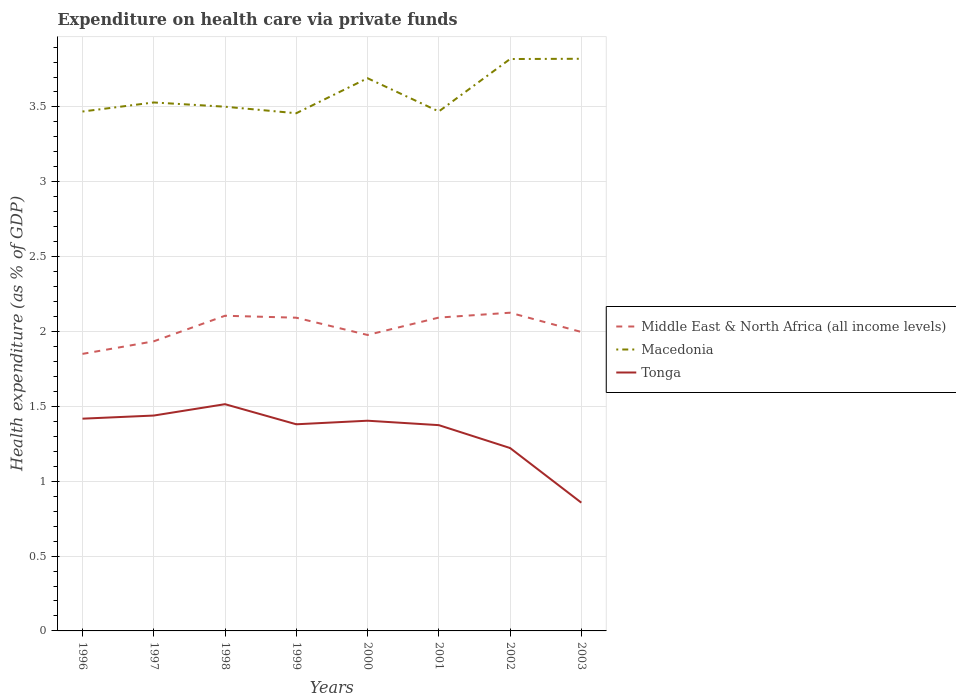How many different coloured lines are there?
Keep it short and to the point. 3. Is the number of lines equal to the number of legend labels?
Your answer should be very brief. Yes. Across all years, what is the maximum expenditure made on health care in Macedonia?
Ensure brevity in your answer.  3.46. In which year was the expenditure made on health care in Tonga maximum?
Make the answer very short. 2003. What is the total expenditure made on health care in Middle East & North Africa (all income levels) in the graph?
Ensure brevity in your answer.  0.11. What is the difference between the highest and the second highest expenditure made on health care in Middle East & North Africa (all income levels)?
Offer a terse response. 0.28. What is the difference between the highest and the lowest expenditure made on health care in Tonga?
Your answer should be very brief. 6. How many years are there in the graph?
Offer a very short reply. 8. What is the difference between two consecutive major ticks on the Y-axis?
Your answer should be compact. 0.5. Are the values on the major ticks of Y-axis written in scientific E-notation?
Your answer should be compact. No. Does the graph contain grids?
Your response must be concise. Yes. Where does the legend appear in the graph?
Provide a succinct answer. Center right. How are the legend labels stacked?
Make the answer very short. Vertical. What is the title of the graph?
Provide a short and direct response. Expenditure on health care via private funds. What is the label or title of the Y-axis?
Offer a terse response. Health expenditure (as % of GDP). What is the Health expenditure (as % of GDP) of Middle East & North Africa (all income levels) in 1996?
Keep it short and to the point. 1.85. What is the Health expenditure (as % of GDP) in Macedonia in 1996?
Provide a succinct answer. 3.47. What is the Health expenditure (as % of GDP) of Tonga in 1996?
Give a very brief answer. 1.42. What is the Health expenditure (as % of GDP) of Middle East & North Africa (all income levels) in 1997?
Your response must be concise. 1.93. What is the Health expenditure (as % of GDP) in Macedonia in 1997?
Offer a very short reply. 3.53. What is the Health expenditure (as % of GDP) in Tonga in 1997?
Ensure brevity in your answer.  1.44. What is the Health expenditure (as % of GDP) of Middle East & North Africa (all income levels) in 1998?
Offer a very short reply. 2.11. What is the Health expenditure (as % of GDP) in Macedonia in 1998?
Make the answer very short. 3.5. What is the Health expenditure (as % of GDP) of Tonga in 1998?
Ensure brevity in your answer.  1.51. What is the Health expenditure (as % of GDP) in Middle East & North Africa (all income levels) in 1999?
Provide a short and direct response. 2.09. What is the Health expenditure (as % of GDP) of Macedonia in 1999?
Your answer should be compact. 3.46. What is the Health expenditure (as % of GDP) of Tonga in 1999?
Your answer should be compact. 1.38. What is the Health expenditure (as % of GDP) in Middle East & North Africa (all income levels) in 2000?
Give a very brief answer. 1.98. What is the Health expenditure (as % of GDP) of Macedonia in 2000?
Provide a short and direct response. 3.69. What is the Health expenditure (as % of GDP) of Tonga in 2000?
Give a very brief answer. 1.4. What is the Health expenditure (as % of GDP) of Middle East & North Africa (all income levels) in 2001?
Ensure brevity in your answer.  2.09. What is the Health expenditure (as % of GDP) of Macedonia in 2001?
Ensure brevity in your answer.  3.47. What is the Health expenditure (as % of GDP) of Tonga in 2001?
Your answer should be very brief. 1.37. What is the Health expenditure (as % of GDP) in Middle East & North Africa (all income levels) in 2002?
Your answer should be very brief. 2.13. What is the Health expenditure (as % of GDP) of Macedonia in 2002?
Keep it short and to the point. 3.82. What is the Health expenditure (as % of GDP) in Tonga in 2002?
Offer a very short reply. 1.22. What is the Health expenditure (as % of GDP) of Middle East & North Africa (all income levels) in 2003?
Offer a terse response. 2. What is the Health expenditure (as % of GDP) in Macedonia in 2003?
Ensure brevity in your answer.  3.82. What is the Health expenditure (as % of GDP) of Tonga in 2003?
Make the answer very short. 0.86. Across all years, what is the maximum Health expenditure (as % of GDP) of Middle East & North Africa (all income levels)?
Provide a succinct answer. 2.13. Across all years, what is the maximum Health expenditure (as % of GDP) in Macedonia?
Provide a short and direct response. 3.82. Across all years, what is the maximum Health expenditure (as % of GDP) of Tonga?
Provide a succinct answer. 1.51. Across all years, what is the minimum Health expenditure (as % of GDP) in Middle East & North Africa (all income levels)?
Give a very brief answer. 1.85. Across all years, what is the minimum Health expenditure (as % of GDP) in Macedonia?
Offer a terse response. 3.46. Across all years, what is the minimum Health expenditure (as % of GDP) in Tonga?
Your response must be concise. 0.86. What is the total Health expenditure (as % of GDP) of Middle East & North Africa (all income levels) in the graph?
Provide a succinct answer. 16.18. What is the total Health expenditure (as % of GDP) in Macedonia in the graph?
Your response must be concise. 28.76. What is the total Health expenditure (as % of GDP) of Tonga in the graph?
Offer a very short reply. 10.61. What is the difference between the Health expenditure (as % of GDP) in Middle East & North Africa (all income levels) in 1996 and that in 1997?
Your answer should be very brief. -0.08. What is the difference between the Health expenditure (as % of GDP) in Macedonia in 1996 and that in 1997?
Your answer should be compact. -0.06. What is the difference between the Health expenditure (as % of GDP) in Tonga in 1996 and that in 1997?
Provide a short and direct response. -0.02. What is the difference between the Health expenditure (as % of GDP) of Middle East & North Africa (all income levels) in 1996 and that in 1998?
Your answer should be compact. -0.25. What is the difference between the Health expenditure (as % of GDP) in Macedonia in 1996 and that in 1998?
Your answer should be very brief. -0.03. What is the difference between the Health expenditure (as % of GDP) in Tonga in 1996 and that in 1998?
Ensure brevity in your answer.  -0.1. What is the difference between the Health expenditure (as % of GDP) in Middle East & North Africa (all income levels) in 1996 and that in 1999?
Make the answer very short. -0.24. What is the difference between the Health expenditure (as % of GDP) of Macedonia in 1996 and that in 1999?
Ensure brevity in your answer.  0.01. What is the difference between the Health expenditure (as % of GDP) in Tonga in 1996 and that in 1999?
Your answer should be very brief. 0.04. What is the difference between the Health expenditure (as % of GDP) of Middle East & North Africa (all income levels) in 1996 and that in 2000?
Your response must be concise. -0.13. What is the difference between the Health expenditure (as % of GDP) in Macedonia in 1996 and that in 2000?
Give a very brief answer. -0.22. What is the difference between the Health expenditure (as % of GDP) of Tonga in 1996 and that in 2000?
Offer a very short reply. 0.01. What is the difference between the Health expenditure (as % of GDP) of Middle East & North Africa (all income levels) in 1996 and that in 2001?
Keep it short and to the point. -0.24. What is the difference between the Health expenditure (as % of GDP) of Macedonia in 1996 and that in 2001?
Your response must be concise. -0. What is the difference between the Health expenditure (as % of GDP) in Tonga in 1996 and that in 2001?
Your response must be concise. 0.04. What is the difference between the Health expenditure (as % of GDP) of Middle East & North Africa (all income levels) in 1996 and that in 2002?
Provide a succinct answer. -0.28. What is the difference between the Health expenditure (as % of GDP) of Macedonia in 1996 and that in 2002?
Your answer should be very brief. -0.35. What is the difference between the Health expenditure (as % of GDP) in Tonga in 1996 and that in 2002?
Provide a succinct answer. 0.2. What is the difference between the Health expenditure (as % of GDP) in Middle East & North Africa (all income levels) in 1996 and that in 2003?
Offer a very short reply. -0.15. What is the difference between the Health expenditure (as % of GDP) of Macedonia in 1996 and that in 2003?
Keep it short and to the point. -0.35. What is the difference between the Health expenditure (as % of GDP) in Tonga in 1996 and that in 2003?
Offer a very short reply. 0.56. What is the difference between the Health expenditure (as % of GDP) of Middle East & North Africa (all income levels) in 1997 and that in 1998?
Your answer should be very brief. -0.17. What is the difference between the Health expenditure (as % of GDP) of Macedonia in 1997 and that in 1998?
Provide a short and direct response. 0.03. What is the difference between the Health expenditure (as % of GDP) in Tonga in 1997 and that in 1998?
Your response must be concise. -0.08. What is the difference between the Health expenditure (as % of GDP) in Middle East & North Africa (all income levels) in 1997 and that in 1999?
Provide a short and direct response. -0.16. What is the difference between the Health expenditure (as % of GDP) in Macedonia in 1997 and that in 1999?
Provide a short and direct response. 0.07. What is the difference between the Health expenditure (as % of GDP) in Tonga in 1997 and that in 1999?
Provide a short and direct response. 0.06. What is the difference between the Health expenditure (as % of GDP) in Middle East & North Africa (all income levels) in 1997 and that in 2000?
Make the answer very short. -0.04. What is the difference between the Health expenditure (as % of GDP) in Macedonia in 1997 and that in 2000?
Ensure brevity in your answer.  -0.16. What is the difference between the Health expenditure (as % of GDP) in Tonga in 1997 and that in 2000?
Your answer should be compact. 0.03. What is the difference between the Health expenditure (as % of GDP) of Middle East & North Africa (all income levels) in 1997 and that in 2001?
Offer a very short reply. -0.16. What is the difference between the Health expenditure (as % of GDP) of Macedonia in 1997 and that in 2001?
Provide a succinct answer. 0.06. What is the difference between the Health expenditure (as % of GDP) of Tonga in 1997 and that in 2001?
Make the answer very short. 0.06. What is the difference between the Health expenditure (as % of GDP) of Middle East & North Africa (all income levels) in 1997 and that in 2002?
Make the answer very short. -0.19. What is the difference between the Health expenditure (as % of GDP) of Macedonia in 1997 and that in 2002?
Your answer should be compact. -0.29. What is the difference between the Health expenditure (as % of GDP) of Tonga in 1997 and that in 2002?
Your answer should be compact. 0.22. What is the difference between the Health expenditure (as % of GDP) of Middle East & North Africa (all income levels) in 1997 and that in 2003?
Make the answer very short. -0.06. What is the difference between the Health expenditure (as % of GDP) of Macedonia in 1997 and that in 2003?
Ensure brevity in your answer.  -0.29. What is the difference between the Health expenditure (as % of GDP) in Tonga in 1997 and that in 2003?
Your answer should be compact. 0.58. What is the difference between the Health expenditure (as % of GDP) of Middle East & North Africa (all income levels) in 1998 and that in 1999?
Provide a succinct answer. 0.01. What is the difference between the Health expenditure (as % of GDP) of Macedonia in 1998 and that in 1999?
Give a very brief answer. 0.04. What is the difference between the Health expenditure (as % of GDP) in Tonga in 1998 and that in 1999?
Your answer should be very brief. 0.13. What is the difference between the Health expenditure (as % of GDP) in Middle East & North Africa (all income levels) in 1998 and that in 2000?
Provide a short and direct response. 0.13. What is the difference between the Health expenditure (as % of GDP) in Macedonia in 1998 and that in 2000?
Ensure brevity in your answer.  -0.19. What is the difference between the Health expenditure (as % of GDP) of Tonga in 1998 and that in 2000?
Ensure brevity in your answer.  0.11. What is the difference between the Health expenditure (as % of GDP) of Middle East & North Africa (all income levels) in 1998 and that in 2001?
Your response must be concise. 0.01. What is the difference between the Health expenditure (as % of GDP) in Macedonia in 1998 and that in 2001?
Keep it short and to the point. 0.03. What is the difference between the Health expenditure (as % of GDP) of Tonga in 1998 and that in 2001?
Provide a short and direct response. 0.14. What is the difference between the Health expenditure (as % of GDP) of Middle East & North Africa (all income levels) in 1998 and that in 2002?
Provide a short and direct response. -0.02. What is the difference between the Health expenditure (as % of GDP) of Macedonia in 1998 and that in 2002?
Your response must be concise. -0.32. What is the difference between the Health expenditure (as % of GDP) of Tonga in 1998 and that in 2002?
Ensure brevity in your answer.  0.29. What is the difference between the Health expenditure (as % of GDP) in Middle East & North Africa (all income levels) in 1998 and that in 2003?
Offer a terse response. 0.11. What is the difference between the Health expenditure (as % of GDP) in Macedonia in 1998 and that in 2003?
Provide a short and direct response. -0.32. What is the difference between the Health expenditure (as % of GDP) of Tonga in 1998 and that in 2003?
Give a very brief answer. 0.66. What is the difference between the Health expenditure (as % of GDP) of Middle East & North Africa (all income levels) in 1999 and that in 2000?
Make the answer very short. 0.12. What is the difference between the Health expenditure (as % of GDP) of Macedonia in 1999 and that in 2000?
Keep it short and to the point. -0.23. What is the difference between the Health expenditure (as % of GDP) of Tonga in 1999 and that in 2000?
Give a very brief answer. -0.02. What is the difference between the Health expenditure (as % of GDP) in Middle East & North Africa (all income levels) in 1999 and that in 2001?
Make the answer very short. -0. What is the difference between the Health expenditure (as % of GDP) of Macedonia in 1999 and that in 2001?
Keep it short and to the point. -0.01. What is the difference between the Health expenditure (as % of GDP) of Tonga in 1999 and that in 2001?
Make the answer very short. 0.01. What is the difference between the Health expenditure (as % of GDP) in Middle East & North Africa (all income levels) in 1999 and that in 2002?
Provide a succinct answer. -0.03. What is the difference between the Health expenditure (as % of GDP) of Macedonia in 1999 and that in 2002?
Your answer should be very brief. -0.36. What is the difference between the Health expenditure (as % of GDP) in Tonga in 1999 and that in 2002?
Provide a succinct answer. 0.16. What is the difference between the Health expenditure (as % of GDP) of Middle East & North Africa (all income levels) in 1999 and that in 2003?
Offer a terse response. 0.1. What is the difference between the Health expenditure (as % of GDP) of Macedonia in 1999 and that in 2003?
Provide a short and direct response. -0.36. What is the difference between the Health expenditure (as % of GDP) in Tonga in 1999 and that in 2003?
Your answer should be very brief. 0.52. What is the difference between the Health expenditure (as % of GDP) in Middle East & North Africa (all income levels) in 2000 and that in 2001?
Provide a succinct answer. -0.12. What is the difference between the Health expenditure (as % of GDP) in Macedonia in 2000 and that in 2001?
Make the answer very short. 0.22. What is the difference between the Health expenditure (as % of GDP) in Tonga in 2000 and that in 2001?
Provide a succinct answer. 0.03. What is the difference between the Health expenditure (as % of GDP) of Middle East & North Africa (all income levels) in 2000 and that in 2002?
Keep it short and to the point. -0.15. What is the difference between the Health expenditure (as % of GDP) of Macedonia in 2000 and that in 2002?
Offer a very short reply. -0.13. What is the difference between the Health expenditure (as % of GDP) in Tonga in 2000 and that in 2002?
Give a very brief answer. 0.18. What is the difference between the Health expenditure (as % of GDP) of Middle East & North Africa (all income levels) in 2000 and that in 2003?
Your response must be concise. -0.02. What is the difference between the Health expenditure (as % of GDP) in Macedonia in 2000 and that in 2003?
Ensure brevity in your answer.  -0.13. What is the difference between the Health expenditure (as % of GDP) of Tonga in 2000 and that in 2003?
Your answer should be compact. 0.55. What is the difference between the Health expenditure (as % of GDP) of Middle East & North Africa (all income levels) in 2001 and that in 2002?
Provide a short and direct response. -0.03. What is the difference between the Health expenditure (as % of GDP) of Macedonia in 2001 and that in 2002?
Offer a very short reply. -0.35. What is the difference between the Health expenditure (as % of GDP) in Tonga in 2001 and that in 2002?
Provide a succinct answer. 0.15. What is the difference between the Health expenditure (as % of GDP) of Middle East & North Africa (all income levels) in 2001 and that in 2003?
Provide a short and direct response. 0.1. What is the difference between the Health expenditure (as % of GDP) in Macedonia in 2001 and that in 2003?
Provide a short and direct response. -0.35. What is the difference between the Health expenditure (as % of GDP) of Tonga in 2001 and that in 2003?
Offer a terse response. 0.52. What is the difference between the Health expenditure (as % of GDP) in Middle East & North Africa (all income levels) in 2002 and that in 2003?
Your answer should be compact. 0.13. What is the difference between the Health expenditure (as % of GDP) in Macedonia in 2002 and that in 2003?
Make the answer very short. -0. What is the difference between the Health expenditure (as % of GDP) in Tonga in 2002 and that in 2003?
Give a very brief answer. 0.37. What is the difference between the Health expenditure (as % of GDP) of Middle East & North Africa (all income levels) in 1996 and the Health expenditure (as % of GDP) of Macedonia in 1997?
Your answer should be compact. -1.68. What is the difference between the Health expenditure (as % of GDP) in Middle East & North Africa (all income levels) in 1996 and the Health expenditure (as % of GDP) in Tonga in 1997?
Offer a very short reply. 0.41. What is the difference between the Health expenditure (as % of GDP) of Macedonia in 1996 and the Health expenditure (as % of GDP) of Tonga in 1997?
Ensure brevity in your answer.  2.03. What is the difference between the Health expenditure (as % of GDP) in Middle East & North Africa (all income levels) in 1996 and the Health expenditure (as % of GDP) in Macedonia in 1998?
Keep it short and to the point. -1.65. What is the difference between the Health expenditure (as % of GDP) of Middle East & North Africa (all income levels) in 1996 and the Health expenditure (as % of GDP) of Tonga in 1998?
Provide a short and direct response. 0.34. What is the difference between the Health expenditure (as % of GDP) in Macedonia in 1996 and the Health expenditure (as % of GDP) in Tonga in 1998?
Make the answer very short. 1.96. What is the difference between the Health expenditure (as % of GDP) in Middle East & North Africa (all income levels) in 1996 and the Health expenditure (as % of GDP) in Macedonia in 1999?
Ensure brevity in your answer.  -1.61. What is the difference between the Health expenditure (as % of GDP) of Middle East & North Africa (all income levels) in 1996 and the Health expenditure (as % of GDP) of Tonga in 1999?
Your answer should be compact. 0.47. What is the difference between the Health expenditure (as % of GDP) of Macedonia in 1996 and the Health expenditure (as % of GDP) of Tonga in 1999?
Make the answer very short. 2.09. What is the difference between the Health expenditure (as % of GDP) in Middle East & North Africa (all income levels) in 1996 and the Health expenditure (as % of GDP) in Macedonia in 2000?
Your answer should be very brief. -1.84. What is the difference between the Health expenditure (as % of GDP) in Middle East & North Africa (all income levels) in 1996 and the Health expenditure (as % of GDP) in Tonga in 2000?
Your response must be concise. 0.45. What is the difference between the Health expenditure (as % of GDP) of Macedonia in 1996 and the Health expenditure (as % of GDP) of Tonga in 2000?
Your answer should be compact. 2.07. What is the difference between the Health expenditure (as % of GDP) in Middle East & North Africa (all income levels) in 1996 and the Health expenditure (as % of GDP) in Macedonia in 2001?
Ensure brevity in your answer.  -1.62. What is the difference between the Health expenditure (as % of GDP) of Middle East & North Africa (all income levels) in 1996 and the Health expenditure (as % of GDP) of Tonga in 2001?
Give a very brief answer. 0.48. What is the difference between the Health expenditure (as % of GDP) of Macedonia in 1996 and the Health expenditure (as % of GDP) of Tonga in 2001?
Ensure brevity in your answer.  2.1. What is the difference between the Health expenditure (as % of GDP) in Middle East & North Africa (all income levels) in 1996 and the Health expenditure (as % of GDP) in Macedonia in 2002?
Offer a very short reply. -1.97. What is the difference between the Health expenditure (as % of GDP) in Middle East & North Africa (all income levels) in 1996 and the Health expenditure (as % of GDP) in Tonga in 2002?
Ensure brevity in your answer.  0.63. What is the difference between the Health expenditure (as % of GDP) in Macedonia in 1996 and the Health expenditure (as % of GDP) in Tonga in 2002?
Provide a succinct answer. 2.25. What is the difference between the Health expenditure (as % of GDP) in Middle East & North Africa (all income levels) in 1996 and the Health expenditure (as % of GDP) in Macedonia in 2003?
Your response must be concise. -1.97. What is the difference between the Health expenditure (as % of GDP) of Macedonia in 1996 and the Health expenditure (as % of GDP) of Tonga in 2003?
Your answer should be compact. 2.61. What is the difference between the Health expenditure (as % of GDP) in Middle East & North Africa (all income levels) in 1997 and the Health expenditure (as % of GDP) in Macedonia in 1998?
Offer a very short reply. -1.57. What is the difference between the Health expenditure (as % of GDP) in Middle East & North Africa (all income levels) in 1997 and the Health expenditure (as % of GDP) in Tonga in 1998?
Offer a terse response. 0.42. What is the difference between the Health expenditure (as % of GDP) in Macedonia in 1997 and the Health expenditure (as % of GDP) in Tonga in 1998?
Make the answer very short. 2.02. What is the difference between the Health expenditure (as % of GDP) in Middle East & North Africa (all income levels) in 1997 and the Health expenditure (as % of GDP) in Macedonia in 1999?
Your response must be concise. -1.52. What is the difference between the Health expenditure (as % of GDP) of Middle East & North Africa (all income levels) in 1997 and the Health expenditure (as % of GDP) of Tonga in 1999?
Your response must be concise. 0.55. What is the difference between the Health expenditure (as % of GDP) in Macedonia in 1997 and the Health expenditure (as % of GDP) in Tonga in 1999?
Your response must be concise. 2.15. What is the difference between the Health expenditure (as % of GDP) in Middle East & North Africa (all income levels) in 1997 and the Health expenditure (as % of GDP) in Macedonia in 2000?
Your response must be concise. -1.76. What is the difference between the Health expenditure (as % of GDP) of Middle East & North Africa (all income levels) in 1997 and the Health expenditure (as % of GDP) of Tonga in 2000?
Provide a succinct answer. 0.53. What is the difference between the Health expenditure (as % of GDP) of Macedonia in 1997 and the Health expenditure (as % of GDP) of Tonga in 2000?
Ensure brevity in your answer.  2.13. What is the difference between the Health expenditure (as % of GDP) of Middle East & North Africa (all income levels) in 1997 and the Health expenditure (as % of GDP) of Macedonia in 2001?
Ensure brevity in your answer.  -1.54. What is the difference between the Health expenditure (as % of GDP) in Middle East & North Africa (all income levels) in 1997 and the Health expenditure (as % of GDP) in Tonga in 2001?
Offer a very short reply. 0.56. What is the difference between the Health expenditure (as % of GDP) of Macedonia in 1997 and the Health expenditure (as % of GDP) of Tonga in 2001?
Your answer should be very brief. 2.16. What is the difference between the Health expenditure (as % of GDP) in Middle East & North Africa (all income levels) in 1997 and the Health expenditure (as % of GDP) in Macedonia in 2002?
Your answer should be very brief. -1.89. What is the difference between the Health expenditure (as % of GDP) in Middle East & North Africa (all income levels) in 1997 and the Health expenditure (as % of GDP) in Tonga in 2002?
Your answer should be very brief. 0.71. What is the difference between the Health expenditure (as % of GDP) in Macedonia in 1997 and the Health expenditure (as % of GDP) in Tonga in 2002?
Give a very brief answer. 2.31. What is the difference between the Health expenditure (as % of GDP) in Middle East & North Africa (all income levels) in 1997 and the Health expenditure (as % of GDP) in Macedonia in 2003?
Your answer should be compact. -1.89. What is the difference between the Health expenditure (as % of GDP) of Middle East & North Africa (all income levels) in 1997 and the Health expenditure (as % of GDP) of Tonga in 2003?
Offer a terse response. 1.08. What is the difference between the Health expenditure (as % of GDP) in Macedonia in 1997 and the Health expenditure (as % of GDP) in Tonga in 2003?
Give a very brief answer. 2.67. What is the difference between the Health expenditure (as % of GDP) in Middle East & North Africa (all income levels) in 1998 and the Health expenditure (as % of GDP) in Macedonia in 1999?
Provide a succinct answer. -1.35. What is the difference between the Health expenditure (as % of GDP) of Middle East & North Africa (all income levels) in 1998 and the Health expenditure (as % of GDP) of Tonga in 1999?
Keep it short and to the point. 0.72. What is the difference between the Health expenditure (as % of GDP) of Macedonia in 1998 and the Health expenditure (as % of GDP) of Tonga in 1999?
Keep it short and to the point. 2.12. What is the difference between the Health expenditure (as % of GDP) in Middle East & North Africa (all income levels) in 1998 and the Health expenditure (as % of GDP) in Macedonia in 2000?
Give a very brief answer. -1.59. What is the difference between the Health expenditure (as % of GDP) of Middle East & North Africa (all income levels) in 1998 and the Health expenditure (as % of GDP) of Tonga in 2000?
Your answer should be very brief. 0.7. What is the difference between the Health expenditure (as % of GDP) of Macedonia in 1998 and the Health expenditure (as % of GDP) of Tonga in 2000?
Your response must be concise. 2.1. What is the difference between the Health expenditure (as % of GDP) in Middle East & North Africa (all income levels) in 1998 and the Health expenditure (as % of GDP) in Macedonia in 2001?
Keep it short and to the point. -1.36. What is the difference between the Health expenditure (as % of GDP) of Middle East & North Africa (all income levels) in 1998 and the Health expenditure (as % of GDP) of Tonga in 2001?
Keep it short and to the point. 0.73. What is the difference between the Health expenditure (as % of GDP) in Macedonia in 1998 and the Health expenditure (as % of GDP) in Tonga in 2001?
Provide a short and direct response. 2.13. What is the difference between the Health expenditure (as % of GDP) of Middle East & North Africa (all income levels) in 1998 and the Health expenditure (as % of GDP) of Macedonia in 2002?
Your answer should be compact. -1.71. What is the difference between the Health expenditure (as % of GDP) in Middle East & North Africa (all income levels) in 1998 and the Health expenditure (as % of GDP) in Tonga in 2002?
Your answer should be very brief. 0.88. What is the difference between the Health expenditure (as % of GDP) of Macedonia in 1998 and the Health expenditure (as % of GDP) of Tonga in 2002?
Offer a very short reply. 2.28. What is the difference between the Health expenditure (as % of GDP) of Middle East & North Africa (all income levels) in 1998 and the Health expenditure (as % of GDP) of Macedonia in 2003?
Provide a short and direct response. -1.72. What is the difference between the Health expenditure (as % of GDP) in Middle East & North Africa (all income levels) in 1998 and the Health expenditure (as % of GDP) in Tonga in 2003?
Give a very brief answer. 1.25. What is the difference between the Health expenditure (as % of GDP) of Macedonia in 1998 and the Health expenditure (as % of GDP) of Tonga in 2003?
Your answer should be compact. 2.65. What is the difference between the Health expenditure (as % of GDP) in Middle East & North Africa (all income levels) in 1999 and the Health expenditure (as % of GDP) in Macedonia in 2000?
Your response must be concise. -1.6. What is the difference between the Health expenditure (as % of GDP) of Middle East & North Africa (all income levels) in 1999 and the Health expenditure (as % of GDP) of Tonga in 2000?
Provide a succinct answer. 0.69. What is the difference between the Health expenditure (as % of GDP) in Macedonia in 1999 and the Health expenditure (as % of GDP) in Tonga in 2000?
Your answer should be compact. 2.05. What is the difference between the Health expenditure (as % of GDP) in Middle East & North Africa (all income levels) in 1999 and the Health expenditure (as % of GDP) in Macedonia in 2001?
Your response must be concise. -1.38. What is the difference between the Health expenditure (as % of GDP) of Middle East & North Africa (all income levels) in 1999 and the Health expenditure (as % of GDP) of Tonga in 2001?
Provide a succinct answer. 0.72. What is the difference between the Health expenditure (as % of GDP) of Macedonia in 1999 and the Health expenditure (as % of GDP) of Tonga in 2001?
Ensure brevity in your answer.  2.08. What is the difference between the Health expenditure (as % of GDP) of Middle East & North Africa (all income levels) in 1999 and the Health expenditure (as % of GDP) of Macedonia in 2002?
Ensure brevity in your answer.  -1.73. What is the difference between the Health expenditure (as % of GDP) of Middle East & North Africa (all income levels) in 1999 and the Health expenditure (as % of GDP) of Tonga in 2002?
Provide a succinct answer. 0.87. What is the difference between the Health expenditure (as % of GDP) in Macedonia in 1999 and the Health expenditure (as % of GDP) in Tonga in 2002?
Your answer should be compact. 2.24. What is the difference between the Health expenditure (as % of GDP) in Middle East & North Africa (all income levels) in 1999 and the Health expenditure (as % of GDP) in Macedonia in 2003?
Ensure brevity in your answer.  -1.73. What is the difference between the Health expenditure (as % of GDP) of Middle East & North Africa (all income levels) in 1999 and the Health expenditure (as % of GDP) of Tonga in 2003?
Keep it short and to the point. 1.24. What is the difference between the Health expenditure (as % of GDP) in Macedonia in 1999 and the Health expenditure (as % of GDP) in Tonga in 2003?
Give a very brief answer. 2.6. What is the difference between the Health expenditure (as % of GDP) in Middle East & North Africa (all income levels) in 2000 and the Health expenditure (as % of GDP) in Macedonia in 2001?
Provide a short and direct response. -1.49. What is the difference between the Health expenditure (as % of GDP) of Middle East & North Africa (all income levels) in 2000 and the Health expenditure (as % of GDP) of Tonga in 2001?
Provide a short and direct response. 0.6. What is the difference between the Health expenditure (as % of GDP) of Macedonia in 2000 and the Health expenditure (as % of GDP) of Tonga in 2001?
Offer a very short reply. 2.32. What is the difference between the Health expenditure (as % of GDP) of Middle East & North Africa (all income levels) in 2000 and the Health expenditure (as % of GDP) of Macedonia in 2002?
Your response must be concise. -1.84. What is the difference between the Health expenditure (as % of GDP) in Middle East & North Africa (all income levels) in 2000 and the Health expenditure (as % of GDP) in Tonga in 2002?
Ensure brevity in your answer.  0.76. What is the difference between the Health expenditure (as % of GDP) in Macedonia in 2000 and the Health expenditure (as % of GDP) in Tonga in 2002?
Offer a very short reply. 2.47. What is the difference between the Health expenditure (as % of GDP) of Middle East & North Africa (all income levels) in 2000 and the Health expenditure (as % of GDP) of Macedonia in 2003?
Make the answer very short. -1.84. What is the difference between the Health expenditure (as % of GDP) in Middle East & North Africa (all income levels) in 2000 and the Health expenditure (as % of GDP) in Tonga in 2003?
Ensure brevity in your answer.  1.12. What is the difference between the Health expenditure (as % of GDP) of Macedonia in 2000 and the Health expenditure (as % of GDP) of Tonga in 2003?
Make the answer very short. 2.84. What is the difference between the Health expenditure (as % of GDP) in Middle East & North Africa (all income levels) in 2001 and the Health expenditure (as % of GDP) in Macedonia in 2002?
Provide a succinct answer. -1.73. What is the difference between the Health expenditure (as % of GDP) of Middle East & North Africa (all income levels) in 2001 and the Health expenditure (as % of GDP) of Tonga in 2002?
Your response must be concise. 0.87. What is the difference between the Health expenditure (as % of GDP) in Macedonia in 2001 and the Health expenditure (as % of GDP) in Tonga in 2002?
Offer a terse response. 2.25. What is the difference between the Health expenditure (as % of GDP) of Middle East & North Africa (all income levels) in 2001 and the Health expenditure (as % of GDP) of Macedonia in 2003?
Offer a very short reply. -1.73. What is the difference between the Health expenditure (as % of GDP) in Middle East & North Africa (all income levels) in 2001 and the Health expenditure (as % of GDP) in Tonga in 2003?
Your answer should be very brief. 1.24. What is the difference between the Health expenditure (as % of GDP) in Macedonia in 2001 and the Health expenditure (as % of GDP) in Tonga in 2003?
Offer a very short reply. 2.61. What is the difference between the Health expenditure (as % of GDP) of Middle East & North Africa (all income levels) in 2002 and the Health expenditure (as % of GDP) of Macedonia in 2003?
Your answer should be very brief. -1.7. What is the difference between the Health expenditure (as % of GDP) of Middle East & North Africa (all income levels) in 2002 and the Health expenditure (as % of GDP) of Tonga in 2003?
Keep it short and to the point. 1.27. What is the difference between the Health expenditure (as % of GDP) of Macedonia in 2002 and the Health expenditure (as % of GDP) of Tonga in 2003?
Provide a short and direct response. 2.96. What is the average Health expenditure (as % of GDP) in Middle East & North Africa (all income levels) per year?
Your answer should be compact. 2.02. What is the average Health expenditure (as % of GDP) in Macedonia per year?
Ensure brevity in your answer.  3.6. What is the average Health expenditure (as % of GDP) of Tonga per year?
Your answer should be very brief. 1.33. In the year 1996, what is the difference between the Health expenditure (as % of GDP) of Middle East & North Africa (all income levels) and Health expenditure (as % of GDP) of Macedonia?
Offer a very short reply. -1.62. In the year 1996, what is the difference between the Health expenditure (as % of GDP) in Middle East & North Africa (all income levels) and Health expenditure (as % of GDP) in Tonga?
Your answer should be compact. 0.43. In the year 1996, what is the difference between the Health expenditure (as % of GDP) of Macedonia and Health expenditure (as % of GDP) of Tonga?
Provide a short and direct response. 2.05. In the year 1997, what is the difference between the Health expenditure (as % of GDP) of Middle East & North Africa (all income levels) and Health expenditure (as % of GDP) of Macedonia?
Your response must be concise. -1.6. In the year 1997, what is the difference between the Health expenditure (as % of GDP) of Middle East & North Africa (all income levels) and Health expenditure (as % of GDP) of Tonga?
Offer a terse response. 0.5. In the year 1997, what is the difference between the Health expenditure (as % of GDP) of Macedonia and Health expenditure (as % of GDP) of Tonga?
Provide a short and direct response. 2.09. In the year 1998, what is the difference between the Health expenditure (as % of GDP) in Middle East & North Africa (all income levels) and Health expenditure (as % of GDP) in Macedonia?
Make the answer very short. -1.4. In the year 1998, what is the difference between the Health expenditure (as % of GDP) of Middle East & North Africa (all income levels) and Health expenditure (as % of GDP) of Tonga?
Your answer should be compact. 0.59. In the year 1998, what is the difference between the Health expenditure (as % of GDP) of Macedonia and Health expenditure (as % of GDP) of Tonga?
Your answer should be very brief. 1.99. In the year 1999, what is the difference between the Health expenditure (as % of GDP) in Middle East & North Africa (all income levels) and Health expenditure (as % of GDP) in Macedonia?
Provide a short and direct response. -1.37. In the year 1999, what is the difference between the Health expenditure (as % of GDP) in Middle East & North Africa (all income levels) and Health expenditure (as % of GDP) in Tonga?
Give a very brief answer. 0.71. In the year 1999, what is the difference between the Health expenditure (as % of GDP) in Macedonia and Health expenditure (as % of GDP) in Tonga?
Provide a short and direct response. 2.08. In the year 2000, what is the difference between the Health expenditure (as % of GDP) of Middle East & North Africa (all income levels) and Health expenditure (as % of GDP) of Macedonia?
Provide a succinct answer. -1.72. In the year 2000, what is the difference between the Health expenditure (as % of GDP) in Middle East & North Africa (all income levels) and Health expenditure (as % of GDP) in Tonga?
Offer a very short reply. 0.57. In the year 2000, what is the difference between the Health expenditure (as % of GDP) of Macedonia and Health expenditure (as % of GDP) of Tonga?
Provide a succinct answer. 2.29. In the year 2001, what is the difference between the Health expenditure (as % of GDP) in Middle East & North Africa (all income levels) and Health expenditure (as % of GDP) in Macedonia?
Your answer should be very brief. -1.38. In the year 2001, what is the difference between the Health expenditure (as % of GDP) in Middle East & North Africa (all income levels) and Health expenditure (as % of GDP) in Tonga?
Provide a short and direct response. 0.72. In the year 2001, what is the difference between the Health expenditure (as % of GDP) in Macedonia and Health expenditure (as % of GDP) in Tonga?
Provide a short and direct response. 2.1. In the year 2002, what is the difference between the Health expenditure (as % of GDP) of Middle East & North Africa (all income levels) and Health expenditure (as % of GDP) of Macedonia?
Ensure brevity in your answer.  -1.69. In the year 2002, what is the difference between the Health expenditure (as % of GDP) of Middle East & North Africa (all income levels) and Health expenditure (as % of GDP) of Tonga?
Provide a short and direct response. 0.9. In the year 2002, what is the difference between the Health expenditure (as % of GDP) of Macedonia and Health expenditure (as % of GDP) of Tonga?
Your answer should be compact. 2.6. In the year 2003, what is the difference between the Health expenditure (as % of GDP) in Middle East & North Africa (all income levels) and Health expenditure (as % of GDP) in Macedonia?
Ensure brevity in your answer.  -1.82. In the year 2003, what is the difference between the Health expenditure (as % of GDP) in Middle East & North Africa (all income levels) and Health expenditure (as % of GDP) in Tonga?
Offer a very short reply. 1.14. In the year 2003, what is the difference between the Health expenditure (as % of GDP) of Macedonia and Health expenditure (as % of GDP) of Tonga?
Your answer should be very brief. 2.97. What is the ratio of the Health expenditure (as % of GDP) in Middle East & North Africa (all income levels) in 1996 to that in 1997?
Offer a terse response. 0.96. What is the ratio of the Health expenditure (as % of GDP) in Macedonia in 1996 to that in 1997?
Offer a very short reply. 0.98. What is the ratio of the Health expenditure (as % of GDP) of Tonga in 1996 to that in 1997?
Offer a very short reply. 0.99. What is the ratio of the Health expenditure (as % of GDP) of Middle East & North Africa (all income levels) in 1996 to that in 1998?
Offer a very short reply. 0.88. What is the ratio of the Health expenditure (as % of GDP) of Tonga in 1996 to that in 1998?
Give a very brief answer. 0.94. What is the ratio of the Health expenditure (as % of GDP) of Middle East & North Africa (all income levels) in 1996 to that in 1999?
Make the answer very short. 0.88. What is the ratio of the Health expenditure (as % of GDP) in Tonga in 1996 to that in 1999?
Your response must be concise. 1.03. What is the ratio of the Health expenditure (as % of GDP) in Middle East & North Africa (all income levels) in 1996 to that in 2000?
Your answer should be very brief. 0.94. What is the ratio of the Health expenditure (as % of GDP) of Macedonia in 1996 to that in 2000?
Make the answer very short. 0.94. What is the ratio of the Health expenditure (as % of GDP) of Tonga in 1996 to that in 2000?
Provide a short and direct response. 1.01. What is the ratio of the Health expenditure (as % of GDP) of Middle East & North Africa (all income levels) in 1996 to that in 2001?
Give a very brief answer. 0.88. What is the ratio of the Health expenditure (as % of GDP) of Tonga in 1996 to that in 2001?
Your response must be concise. 1.03. What is the ratio of the Health expenditure (as % of GDP) of Middle East & North Africa (all income levels) in 1996 to that in 2002?
Provide a short and direct response. 0.87. What is the ratio of the Health expenditure (as % of GDP) of Macedonia in 1996 to that in 2002?
Give a very brief answer. 0.91. What is the ratio of the Health expenditure (as % of GDP) in Tonga in 1996 to that in 2002?
Provide a succinct answer. 1.16. What is the ratio of the Health expenditure (as % of GDP) of Middle East & North Africa (all income levels) in 1996 to that in 2003?
Provide a short and direct response. 0.93. What is the ratio of the Health expenditure (as % of GDP) in Macedonia in 1996 to that in 2003?
Your answer should be very brief. 0.91. What is the ratio of the Health expenditure (as % of GDP) of Tonga in 1996 to that in 2003?
Keep it short and to the point. 1.66. What is the ratio of the Health expenditure (as % of GDP) in Middle East & North Africa (all income levels) in 1997 to that in 1998?
Offer a very short reply. 0.92. What is the ratio of the Health expenditure (as % of GDP) of Macedonia in 1997 to that in 1998?
Your answer should be very brief. 1.01. What is the ratio of the Health expenditure (as % of GDP) of Tonga in 1997 to that in 1998?
Ensure brevity in your answer.  0.95. What is the ratio of the Health expenditure (as % of GDP) in Middle East & North Africa (all income levels) in 1997 to that in 1999?
Offer a terse response. 0.92. What is the ratio of the Health expenditure (as % of GDP) in Macedonia in 1997 to that in 1999?
Your answer should be compact. 1.02. What is the ratio of the Health expenditure (as % of GDP) in Tonga in 1997 to that in 1999?
Ensure brevity in your answer.  1.04. What is the ratio of the Health expenditure (as % of GDP) in Middle East & North Africa (all income levels) in 1997 to that in 2000?
Provide a short and direct response. 0.98. What is the ratio of the Health expenditure (as % of GDP) in Macedonia in 1997 to that in 2000?
Offer a very short reply. 0.96. What is the ratio of the Health expenditure (as % of GDP) in Tonga in 1997 to that in 2000?
Provide a short and direct response. 1.02. What is the ratio of the Health expenditure (as % of GDP) of Middle East & North Africa (all income levels) in 1997 to that in 2001?
Offer a terse response. 0.92. What is the ratio of the Health expenditure (as % of GDP) of Macedonia in 1997 to that in 2001?
Offer a very short reply. 1.02. What is the ratio of the Health expenditure (as % of GDP) in Tonga in 1997 to that in 2001?
Offer a terse response. 1.05. What is the ratio of the Health expenditure (as % of GDP) in Middle East & North Africa (all income levels) in 1997 to that in 2002?
Keep it short and to the point. 0.91. What is the ratio of the Health expenditure (as % of GDP) of Macedonia in 1997 to that in 2002?
Make the answer very short. 0.92. What is the ratio of the Health expenditure (as % of GDP) in Tonga in 1997 to that in 2002?
Make the answer very short. 1.18. What is the ratio of the Health expenditure (as % of GDP) in Middle East & North Africa (all income levels) in 1997 to that in 2003?
Offer a very short reply. 0.97. What is the ratio of the Health expenditure (as % of GDP) of Macedonia in 1997 to that in 2003?
Offer a very short reply. 0.92. What is the ratio of the Health expenditure (as % of GDP) in Tonga in 1997 to that in 2003?
Make the answer very short. 1.68. What is the ratio of the Health expenditure (as % of GDP) of Macedonia in 1998 to that in 1999?
Your answer should be compact. 1.01. What is the ratio of the Health expenditure (as % of GDP) of Tonga in 1998 to that in 1999?
Provide a succinct answer. 1.1. What is the ratio of the Health expenditure (as % of GDP) of Middle East & North Africa (all income levels) in 1998 to that in 2000?
Offer a terse response. 1.06. What is the ratio of the Health expenditure (as % of GDP) in Macedonia in 1998 to that in 2000?
Give a very brief answer. 0.95. What is the ratio of the Health expenditure (as % of GDP) in Tonga in 1998 to that in 2000?
Make the answer very short. 1.08. What is the ratio of the Health expenditure (as % of GDP) in Middle East & North Africa (all income levels) in 1998 to that in 2001?
Keep it short and to the point. 1.01. What is the ratio of the Health expenditure (as % of GDP) of Macedonia in 1998 to that in 2001?
Keep it short and to the point. 1.01. What is the ratio of the Health expenditure (as % of GDP) in Tonga in 1998 to that in 2001?
Make the answer very short. 1.1. What is the ratio of the Health expenditure (as % of GDP) in Middle East & North Africa (all income levels) in 1998 to that in 2002?
Offer a terse response. 0.99. What is the ratio of the Health expenditure (as % of GDP) in Macedonia in 1998 to that in 2002?
Give a very brief answer. 0.92. What is the ratio of the Health expenditure (as % of GDP) in Tonga in 1998 to that in 2002?
Give a very brief answer. 1.24. What is the ratio of the Health expenditure (as % of GDP) of Middle East & North Africa (all income levels) in 1998 to that in 2003?
Offer a very short reply. 1.05. What is the ratio of the Health expenditure (as % of GDP) in Macedonia in 1998 to that in 2003?
Offer a terse response. 0.92. What is the ratio of the Health expenditure (as % of GDP) of Tonga in 1998 to that in 2003?
Ensure brevity in your answer.  1.77. What is the ratio of the Health expenditure (as % of GDP) in Middle East & North Africa (all income levels) in 1999 to that in 2000?
Offer a very short reply. 1.06. What is the ratio of the Health expenditure (as % of GDP) of Macedonia in 1999 to that in 2000?
Offer a terse response. 0.94. What is the ratio of the Health expenditure (as % of GDP) of Tonga in 1999 to that in 2000?
Your response must be concise. 0.98. What is the ratio of the Health expenditure (as % of GDP) of Middle East & North Africa (all income levels) in 1999 to that in 2001?
Provide a succinct answer. 1. What is the ratio of the Health expenditure (as % of GDP) in Tonga in 1999 to that in 2001?
Make the answer very short. 1. What is the ratio of the Health expenditure (as % of GDP) in Middle East & North Africa (all income levels) in 1999 to that in 2002?
Offer a terse response. 0.98. What is the ratio of the Health expenditure (as % of GDP) of Macedonia in 1999 to that in 2002?
Provide a short and direct response. 0.91. What is the ratio of the Health expenditure (as % of GDP) in Tonga in 1999 to that in 2002?
Your response must be concise. 1.13. What is the ratio of the Health expenditure (as % of GDP) in Middle East & North Africa (all income levels) in 1999 to that in 2003?
Your answer should be compact. 1.05. What is the ratio of the Health expenditure (as % of GDP) in Macedonia in 1999 to that in 2003?
Offer a very short reply. 0.9. What is the ratio of the Health expenditure (as % of GDP) in Tonga in 1999 to that in 2003?
Offer a very short reply. 1.61. What is the ratio of the Health expenditure (as % of GDP) of Middle East & North Africa (all income levels) in 2000 to that in 2001?
Your answer should be compact. 0.94. What is the ratio of the Health expenditure (as % of GDP) of Macedonia in 2000 to that in 2001?
Your answer should be very brief. 1.06. What is the ratio of the Health expenditure (as % of GDP) of Tonga in 2000 to that in 2001?
Offer a very short reply. 1.02. What is the ratio of the Health expenditure (as % of GDP) in Middle East & North Africa (all income levels) in 2000 to that in 2002?
Provide a succinct answer. 0.93. What is the ratio of the Health expenditure (as % of GDP) in Macedonia in 2000 to that in 2002?
Make the answer very short. 0.97. What is the ratio of the Health expenditure (as % of GDP) in Tonga in 2000 to that in 2002?
Provide a short and direct response. 1.15. What is the ratio of the Health expenditure (as % of GDP) of Macedonia in 2000 to that in 2003?
Offer a very short reply. 0.97. What is the ratio of the Health expenditure (as % of GDP) in Tonga in 2000 to that in 2003?
Your answer should be very brief. 1.64. What is the ratio of the Health expenditure (as % of GDP) of Middle East & North Africa (all income levels) in 2001 to that in 2002?
Ensure brevity in your answer.  0.98. What is the ratio of the Health expenditure (as % of GDP) of Macedonia in 2001 to that in 2002?
Provide a succinct answer. 0.91. What is the ratio of the Health expenditure (as % of GDP) of Tonga in 2001 to that in 2002?
Offer a very short reply. 1.13. What is the ratio of the Health expenditure (as % of GDP) of Middle East & North Africa (all income levels) in 2001 to that in 2003?
Give a very brief answer. 1.05. What is the ratio of the Health expenditure (as % of GDP) of Macedonia in 2001 to that in 2003?
Your answer should be compact. 0.91. What is the ratio of the Health expenditure (as % of GDP) of Tonga in 2001 to that in 2003?
Your response must be concise. 1.6. What is the ratio of the Health expenditure (as % of GDP) of Middle East & North Africa (all income levels) in 2002 to that in 2003?
Your answer should be very brief. 1.06. What is the ratio of the Health expenditure (as % of GDP) in Tonga in 2002 to that in 2003?
Your response must be concise. 1.43. What is the difference between the highest and the second highest Health expenditure (as % of GDP) of Middle East & North Africa (all income levels)?
Provide a short and direct response. 0.02. What is the difference between the highest and the second highest Health expenditure (as % of GDP) in Macedonia?
Your answer should be very brief. 0. What is the difference between the highest and the second highest Health expenditure (as % of GDP) of Tonga?
Provide a succinct answer. 0.08. What is the difference between the highest and the lowest Health expenditure (as % of GDP) of Middle East & North Africa (all income levels)?
Offer a terse response. 0.28. What is the difference between the highest and the lowest Health expenditure (as % of GDP) in Macedonia?
Your answer should be compact. 0.36. What is the difference between the highest and the lowest Health expenditure (as % of GDP) of Tonga?
Make the answer very short. 0.66. 